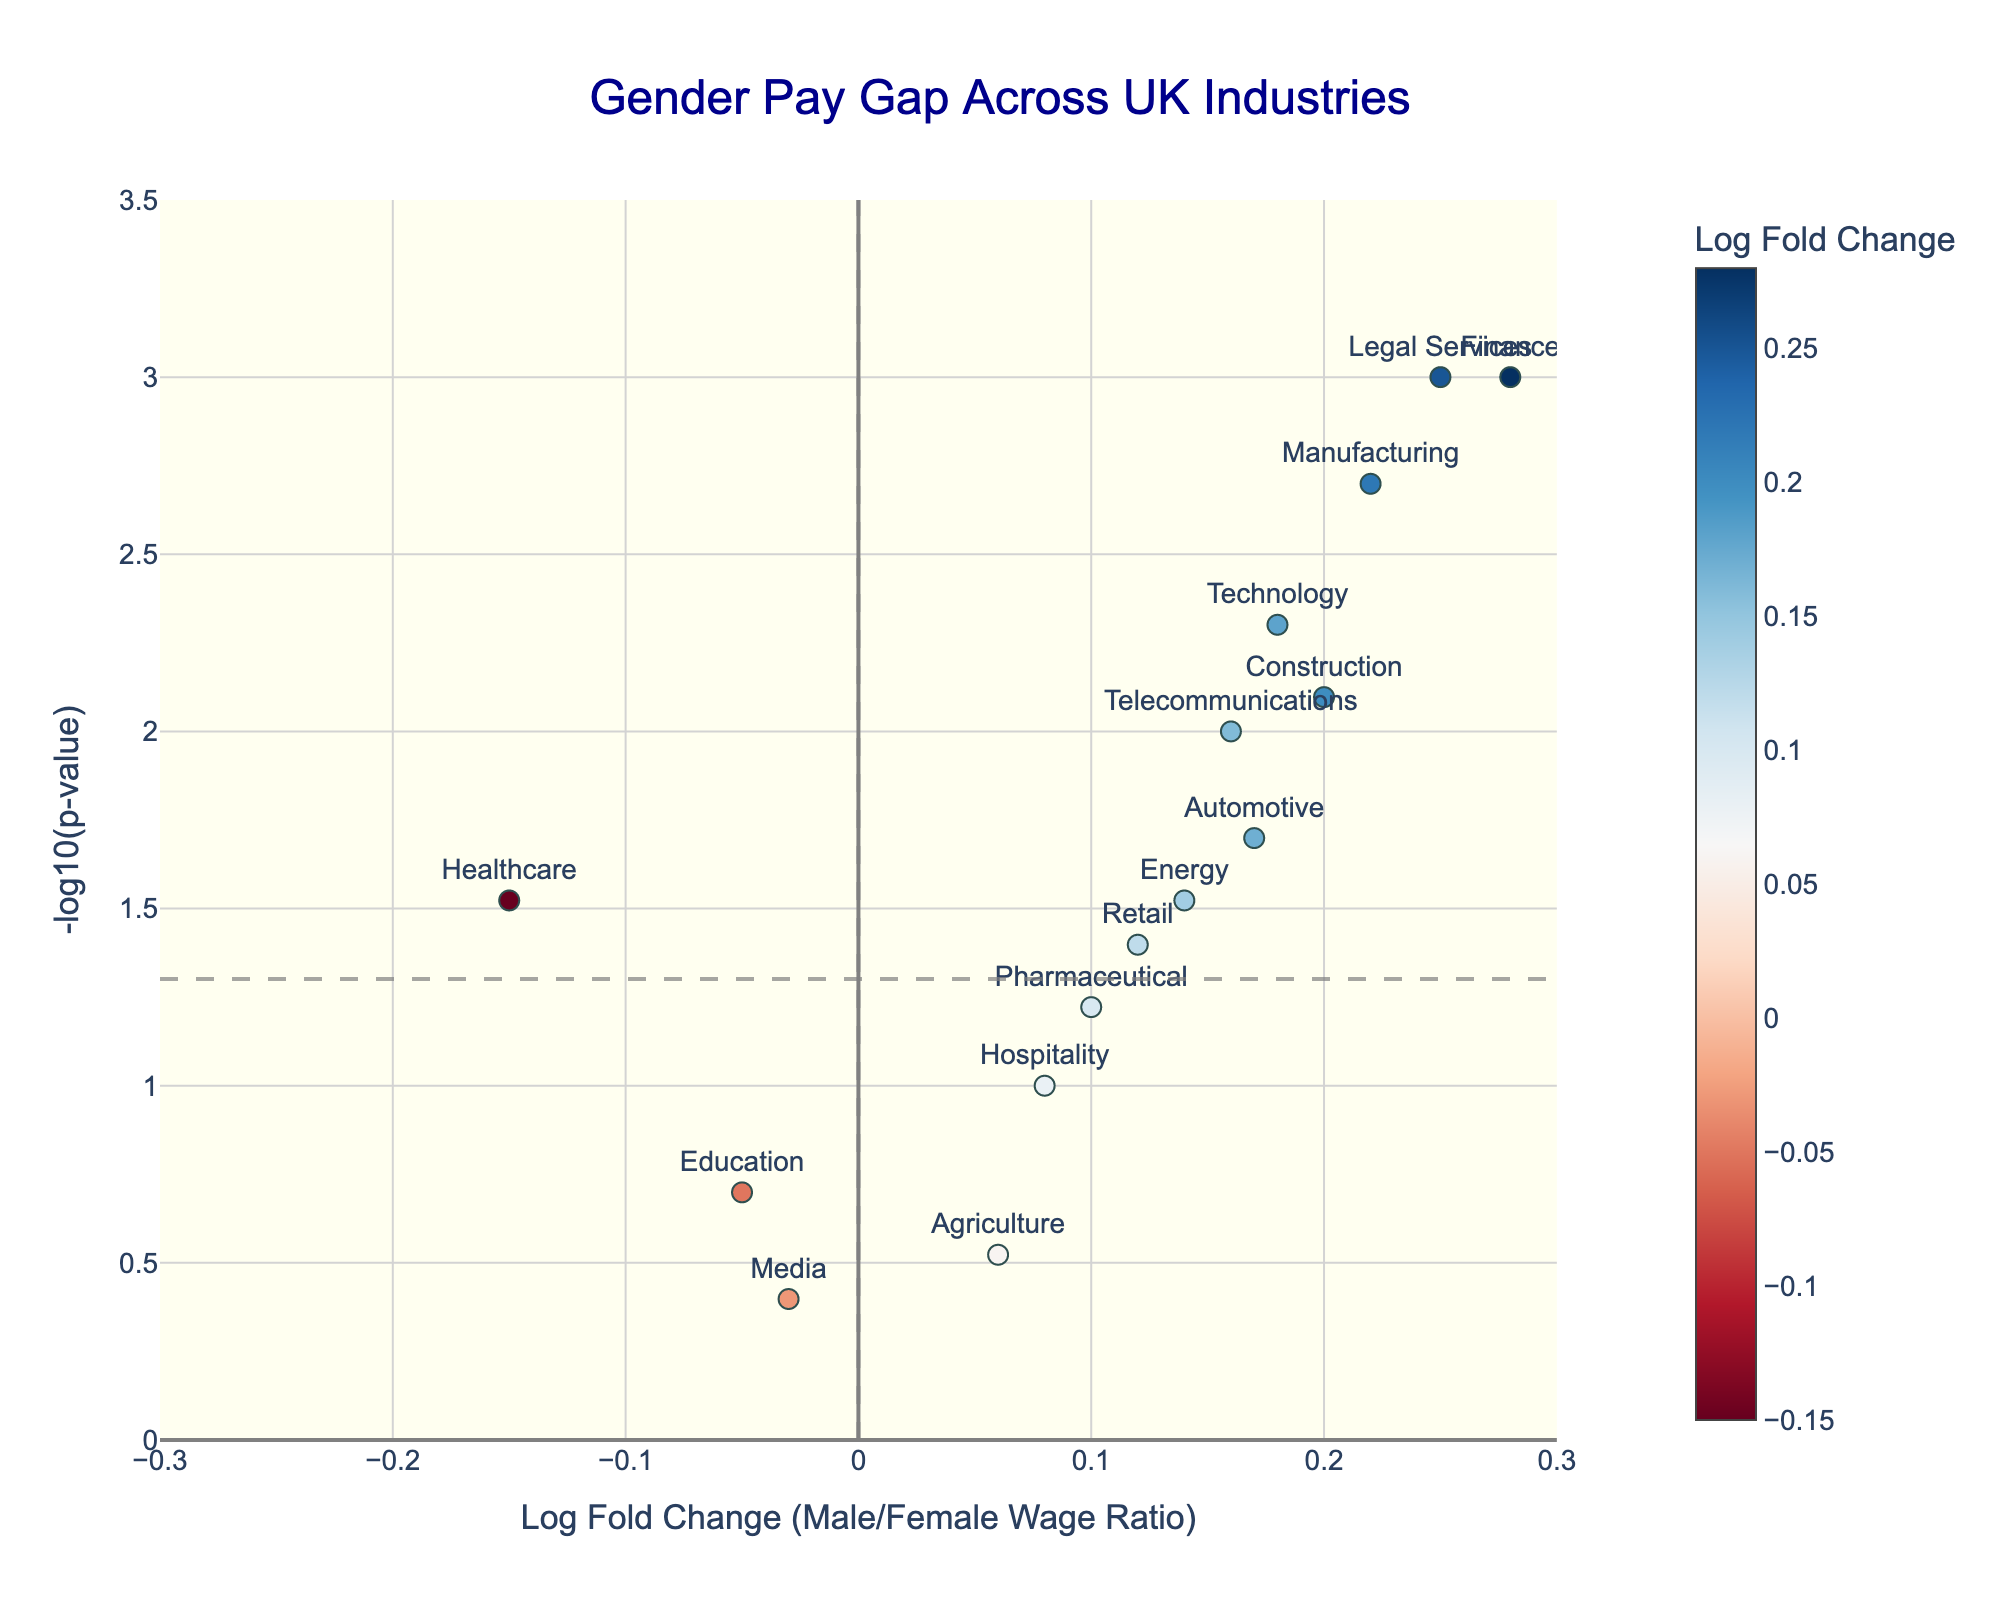What is the title of the plot? The title is located at the top center of the plot in large, blue font. The title reads "Gender Pay Gap Across UK Industries".
Answer: Gender Pay Gap Across UK Industries Which industry shows the largest positive Log Fold Change? By observing the x-axis values for Log Fold Change, the industry with the largest positive Log Fold Change is "Finance".
Answer: Finance Is the gender pay gap in the Automotive industry statistically significant? To determine statistical significance, check whether the point for Automotive is above the horizontal line marked at y = -log10(0.05). The point for Automotive (17% fold change) is above this line, indicating significance.
Answer: Yes Which industry has the most statistically significant negative Log Fold Change? Negative Log Fold Change values lie to the left of the vertical line at x=0. The most significant (highest y-value) among these is "Healthcare".
Answer: Healthcare How many industries show a statistically significant pay gap? Count the number of points above the horizontal line at y = -log10(0.05). These points belong to "Finance", "Technology", "Manufacturing", "Legal Services", "Construction", "Automotive", "Healthcare", and "Telecommunications".
Answer: 8 What's the range of Log Fold Change values represented in the plot? The x-axis values range from the minimum to the maximum Log Fold Change values depicted. Observing the plot, the range is from approximately -0.15 (Healthcare) to 0.28 (Finance and Legal Services).
Answer: -0.15 to 0.28 Which industry has a p-value closest to 0.05? Check the y-axis values, focusing on points near the horizontal line at y = -log10(0.05). "Retail" appears to be closest to the 0.05 threshold with a p-value of 0.04.
Answer: Retail Compare the Log Fold Change of the Technology and Energy industries. Which one is greater? By looking at the x-values of both "Technology" and "Energy", the value for Technology is 0.18 whereas for Energy it's 0.14, making Technology greater.
Answer: Technology Which industry has the smallest magnitude of Log Fold Change, and what is its value? Examine x-axis for the smallest absolute value (ignoring the sign). "Media" has the smallest magnitude with a Log Fold Change of -0.03.
Answer: Media, -0.03 What is the color range used for the markers in the plot? The color scale ranges from shades of red for negative Log Fold Change values to shades of blue for positive values. The color bar alongside the plot indicates this gradient.
Answer: Red to blue 